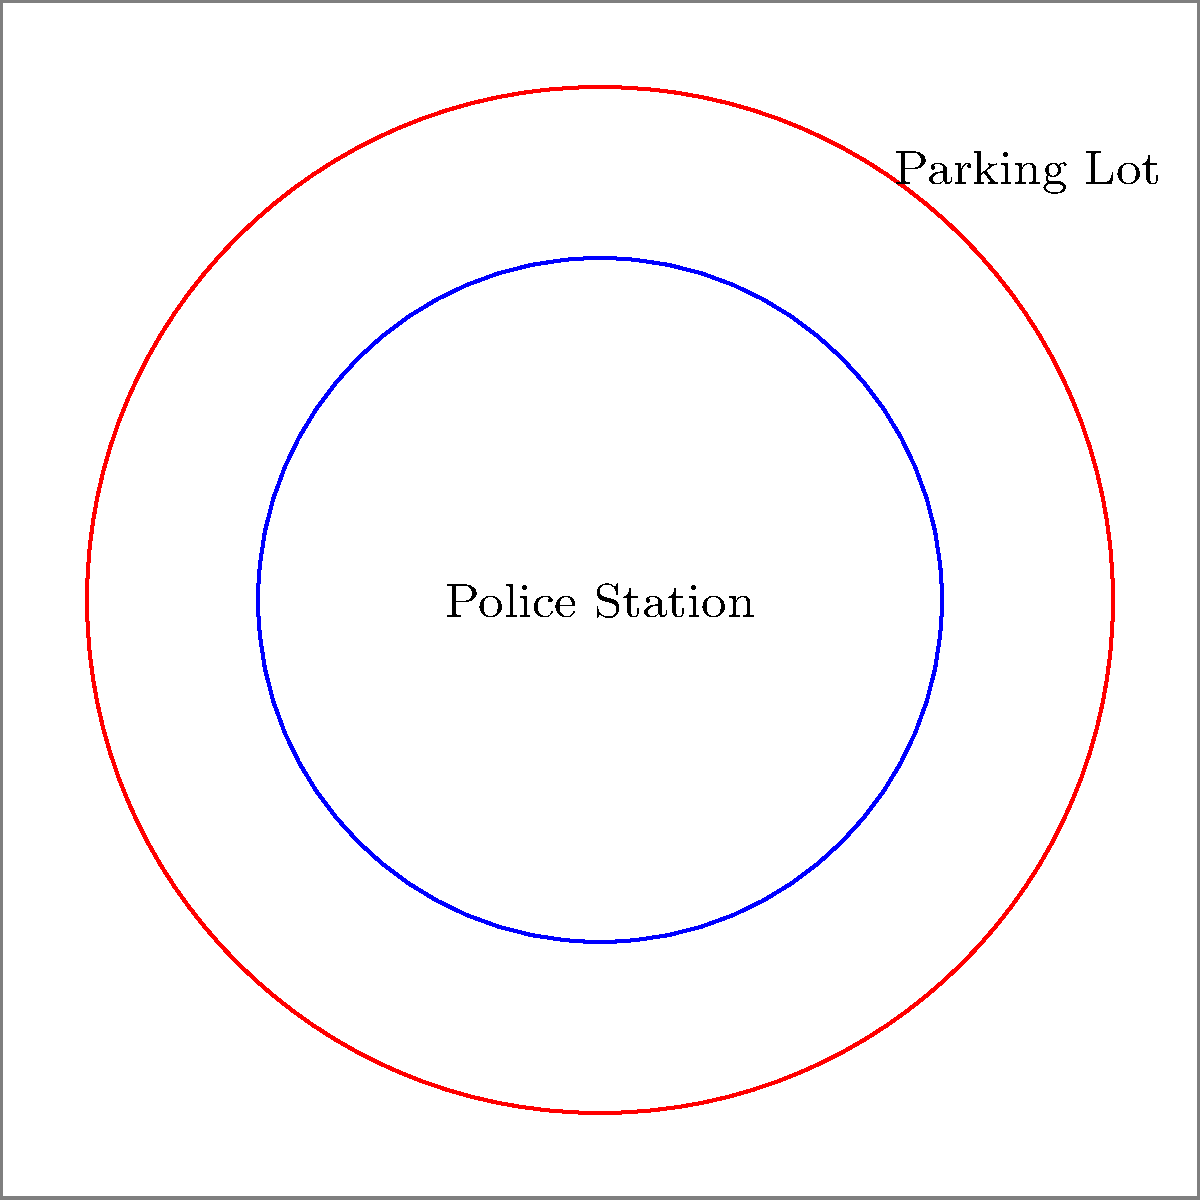The city plans to construct a new circular police station with a radius of 20 meters. To accommodate vehicles, a circular parking lot will surround the station, extending an additional 10 meters in all directions. What is the total area of the police station and its parking lot combined? Let's approach this step-by-step:

1) First, we need to calculate the area of the police station:
   - Radius of police station = 20 meters
   - Area of police station = $\pi r^2 = \pi (20)^2 = 400\pi$ square meters

2) Next, we calculate the area of the entire property (police station + parking lot):
   - Radius of entire property = 20 + 10 = 30 meters
   - Area of entire property = $\pi r^2 = \pi (30)^2 = 900\pi$ square meters

3) To find the area of just the parking lot, we subtract the area of the police station from the area of the entire property:
   - Area of parking lot = Area of entire property - Area of police station
   - Area of parking lot = $900\pi - 400\pi = 500\pi$ square meters

4) The total area is the sum of the police station area and the parking lot area:
   - Total area = Area of police station + Area of parking lot
   - Total area = $400\pi + 500\pi = 900\pi$ square meters

Therefore, the total area of the police station and its parking lot combined is $900\pi$ square meters.
Answer: $900\pi$ square meters 